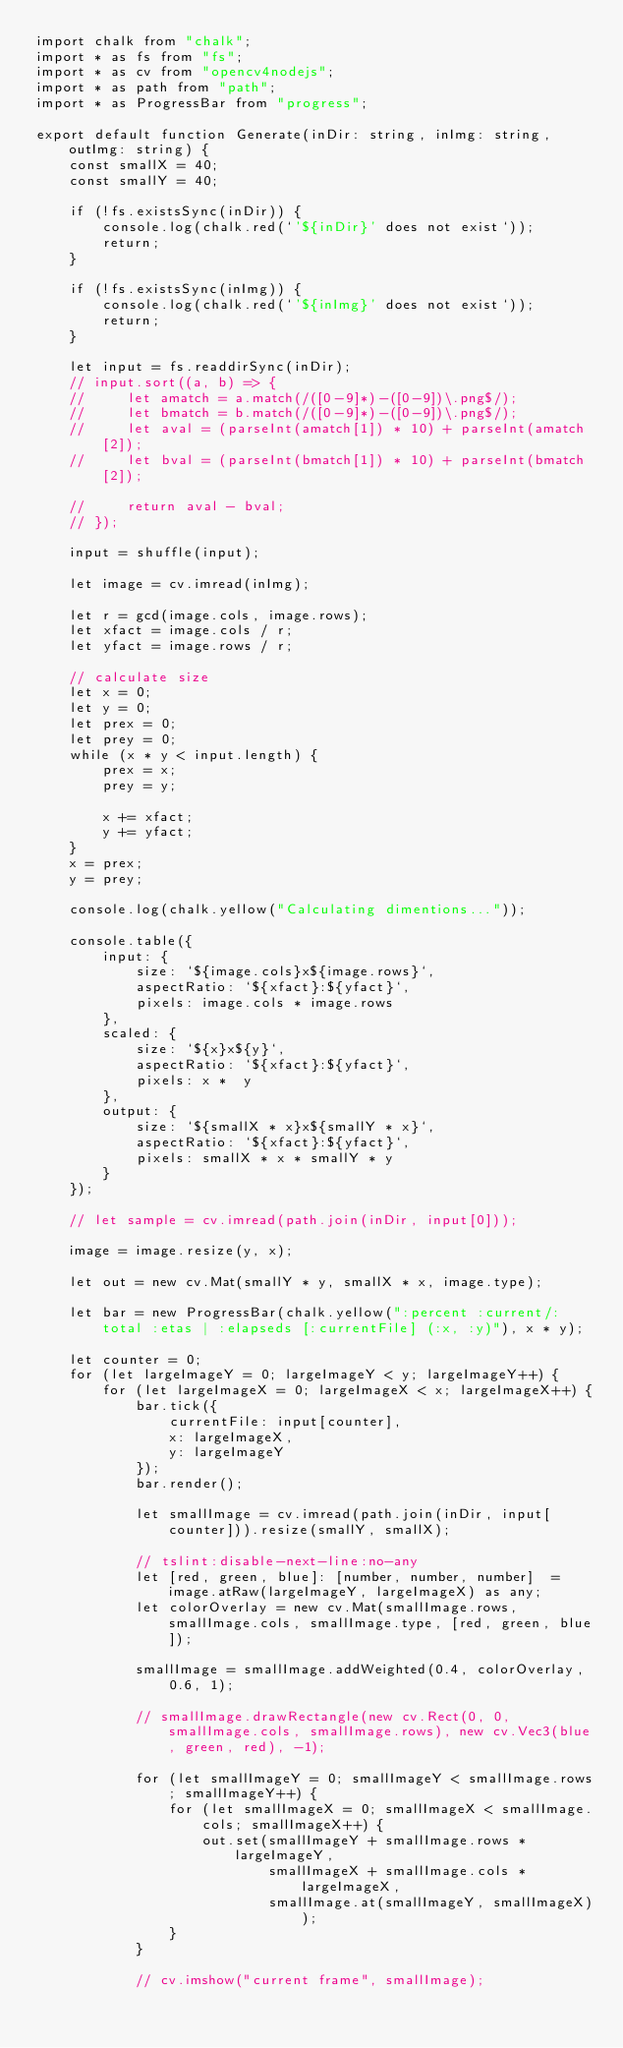<code> <loc_0><loc_0><loc_500><loc_500><_TypeScript_>import chalk from "chalk";
import * as fs from "fs";
import * as cv from "opencv4nodejs";
import * as path from "path";
import * as ProgressBar from "progress";

export default function Generate(inDir: string, inImg: string, outImg: string) {
    const smallX = 40;
    const smallY = 40;

    if (!fs.existsSync(inDir)) {
        console.log(chalk.red(`'${inDir}' does not exist`));
        return;
    }

    if (!fs.existsSync(inImg)) {
        console.log(chalk.red(`'${inImg}' does not exist`));
        return;
    }

    let input = fs.readdirSync(inDir);
    // input.sort((a, b) => {
    //     let amatch = a.match(/([0-9]*)-([0-9])\.png$/);
    //     let bmatch = b.match(/([0-9]*)-([0-9])\.png$/);
    //     let aval = (parseInt(amatch[1]) * 10) + parseInt(amatch[2]);
    //     let bval = (parseInt(bmatch[1]) * 10) + parseInt(bmatch[2]);

    //     return aval - bval;
    // });

    input = shuffle(input);

    let image = cv.imread(inImg);

    let r = gcd(image.cols, image.rows);
    let xfact = image.cols / r;
    let yfact = image.rows / r;

    // calculate size
    let x = 0;
    let y = 0;
    let prex = 0;
    let prey = 0;
    while (x * y < input.length) {
        prex = x;
        prey = y;

        x += xfact;
        y += yfact;
    }
    x = prex;
    y = prey;

    console.log(chalk.yellow("Calculating dimentions..."));

    console.table({
        input: {
            size: `${image.cols}x${image.rows}`,
            aspectRatio: `${xfact}:${yfact}`,
            pixels: image.cols * image.rows
        },
        scaled: {
            size: `${x}x${y}`,
            aspectRatio: `${xfact}:${yfact}`,
            pixels: x *  y
        },
        output: {
            size: `${smallX * x}x${smallY * x}`,
            aspectRatio: `${xfact}:${yfact}`,
            pixels: smallX * x * smallY * y
        }
    });

    // let sample = cv.imread(path.join(inDir, input[0]));

    image = image.resize(y, x);

    let out = new cv.Mat(smallY * y, smallX * x, image.type);

    let bar = new ProgressBar(chalk.yellow(":percent :current/:total :etas | :elapseds [:currentFile] (:x, :y)"), x * y);

    let counter = 0;
    for (let largeImageY = 0; largeImageY < y; largeImageY++) {
        for (let largeImageX = 0; largeImageX < x; largeImageX++) {
            bar.tick({
                currentFile: input[counter],
                x: largeImageX,
                y: largeImageY
            });
            bar.render();

            let smallImage = cv.imread(path.join(inDir, input[counter])).resize(smallY, smallX);

            // tslint:disable-next-line:no-any
            let [red, green, blue]: [number, number, number]  = image.atRaw(largeImageY, largeImageX) as any;
            let colorOverlay = new cv.Mat(smallImage.rows, smallImage.cols, smallImage.type, [red, green, blue]);

            smallImage = smallImage.addWeighted(0.4, colorOverlay, 0.6, 1);

            // smallImage.drawRectangle(new cv.Rect(0, 0, smallImage.cols, smallImage.rows), new cv.Vec3(blue, green, red), -1);

            for (let smallImageY = 0; smallImageY < smallImage.rows; smallImageY++) {
                for (let smallImageX = 0; smallImageX < smallImage.cols; smallImageX++) {
                    out.set(smallImageY + smallImage.rows * largeImageY,
                            smallImageX + smallImage.cols * largeImageX,
                            smallImage.at(smallImageY, smallImageX));
                }
            }

            // cv.imshow("current frame", smallImage);</code> 